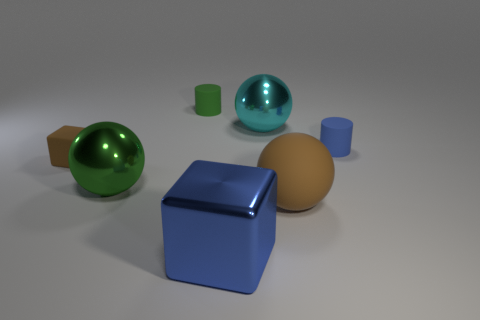What number of tiny rubber objects are both behind the tiny brown thing and left of the large block?
Make the answer very short. 1. What is the shape of the green object behind the cyan shiny object?
Offer a very short reply. Cylinder. Do the matte ball that is to the right of the small brown thing and the tiny rubber block have the same color?
Offer a very short reply. Yes. What material is the object that is in front of the blue cylinder and to the right of the cyan metal object?
Provide a short and direct response. Rubber. Is there a tiny object that has the same color as the large block?
Your answer should be compact. Yes. There is a cylinder in front of the cyan shiny object; is its color the same as the tiny matte thing on the left side of the tiny green rubber cylinder?
Give a very brief answer. No. Is the number of blue shiny cubes on the right side of the green ball less than the number of tiny purple metallic cylinders?
Your answer should be very brief. No. What number of things are either small matte cylinders or big blue things that are on the left side of the brown ball?
Your answer should be very brief. 3. There is a large ball that is made of the same material as the blue cylinder; what is its color?
Make the answer very short. Brown. How many objects are either small yellow blocks or big blocks?
Provide a short and direct response. 1. 